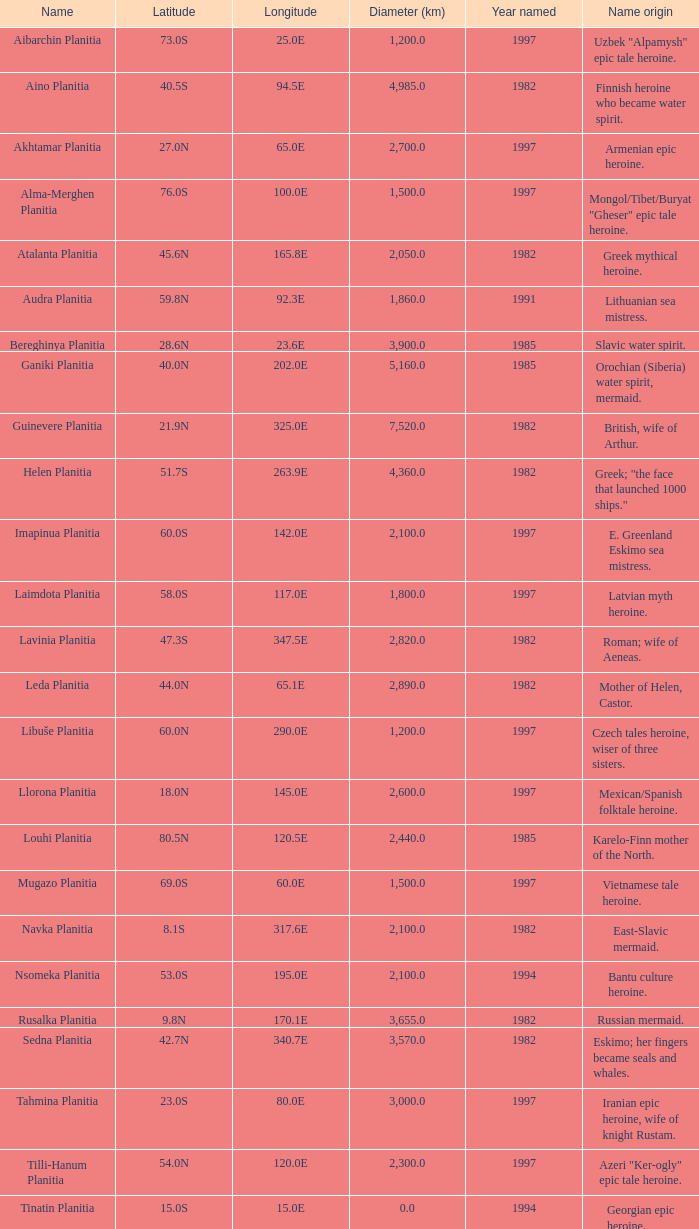What is the latitude of the feature of longitude 80.0e 23.0S. Can you give me this table as a dict? {'header': ['Name', 'Latitude', 'Longitude', 'Diameter (km)', 'Year named', 'Name origin'], 'rows': [['Aibarchin Planitia', '73.0S', '25.0E', '1,200.0', '1997', 'Uzbek "Alpamysh" epic tale heroine.'], ['Aino Planitia', '40.5S', '94.5E', '4,985.0', '1982', 'Finnish heroine who became water spirit.'], ['Akhtamar Planitia', '27.0N', '65.0E', '2,700.0', '1997', 'Armenian epic heroine.'], ['Alma-Merghen Planitia', '76.0S', '100.0E', '1,500.0', '1997', 'Mongol/Tibet/Buryat "Gheser" epic tale heroine.'], ['Atalanta Planitia', '45.6N', '165.8E', '2,050.0', '1982', 'Greek mythical heroine.'], ['Audra Planitia', '59.8N', '92.3E', '1,860.0', '1991', 'Lithuanian sea mistress.'], ['Bereghinya Planitia', '28.6N', '23.6E', '3,900.0', '1985', 'Slavic water spirit.'], ['Ganiki Planitia', '40.0N', '202.0E', '5,160.0', '1985', 'Orochian (Siberia) water spirit, mermaid.'], ['Guinevere Planitia', '21.9N', '325.0E', '7,520.0', '1982', 'British, wife of Arthur.'], ['Helen Planitia', '51.7S', '263.9E', '4,360.0', '1982', 'Greek; "the face that launched 1000 ships."'], ['Imapinua Planitia', '60.0S', '142.0E', '2,100.0', '1997', 'E. Greenland Eskimo sea mistress.'], ['Laimdota Planitia', '58.0S', '117.0E', '1,800.0', '1997', 'Latvian myth heroine.'], ['Lavinia Planitia', '47.3S', '347.5E', '2,820.0', '1982', 'Roman; wife of Aeneas.'], ['Leda Planitia', '44.0N', '65.1E', '2,890.0', '1982', 'Mother of Helen, Castor.'], ['Libuše Planitia', '60.0N', '290.0E', '1,200.0', '1997', 'Czech tales heroine, wiser of three sisters.'], ['Llorona Planitia', '18.0N', '145.0E', '2,600.0', '1997', 'Mexican/Spanish folktale heroine.'], ['Louhi Planitia', '80.5N', '120.5E', '2,440.0', '1985', 'Karelo-Finn mother of the North.'], ['Mugazo Planitia', '69.0S', '60.0E', '1,500.0', '1997', 'Vietnamese tale heroine.'], ['Navka Planitia', '8.1S', '317.6E', '2,100.0', '1982', 'East-Slavic mermaid.'], ['Nsomeka Planitia', '53.0S', '195.0E', '2,100.0', '1994', 'Bantu culture heroine.'], ['Rusalka Planitia', '9.8N', '170.1E', '3,655.0', '1982', 'Russian mermaid.'], ['Sedna Planitia', '42.7N', '340.7E', '3,570.0', '1982', 'Eskimo; her fingers became seals and whales.'], ['Tahmina Planitia', '23.0S', '80.0E', '3,000.0', '1997', 'Iranian epic heroine, wife of knight Rustam.'], ['Tilli-Hanum Planitia', '54.0N', '120.0E', '2,300.0', '1997', 'Azeri "Ker-ogly" epic tale heroine.'], ['Tinatin Planitia', '15.0S', '15.0E', '0.0', '1994', 'Georgian epic heroine.'], ['Undine Planitia', '13.0N', '303.0E', '2,800.0', '1997', 'Lithuanian water nymph, mermaid.'], ['Vellamo Planitia', '45.4N', '149.1E', '2,155.0', '1985', 'Karelo-Finn mermaid.']]} 